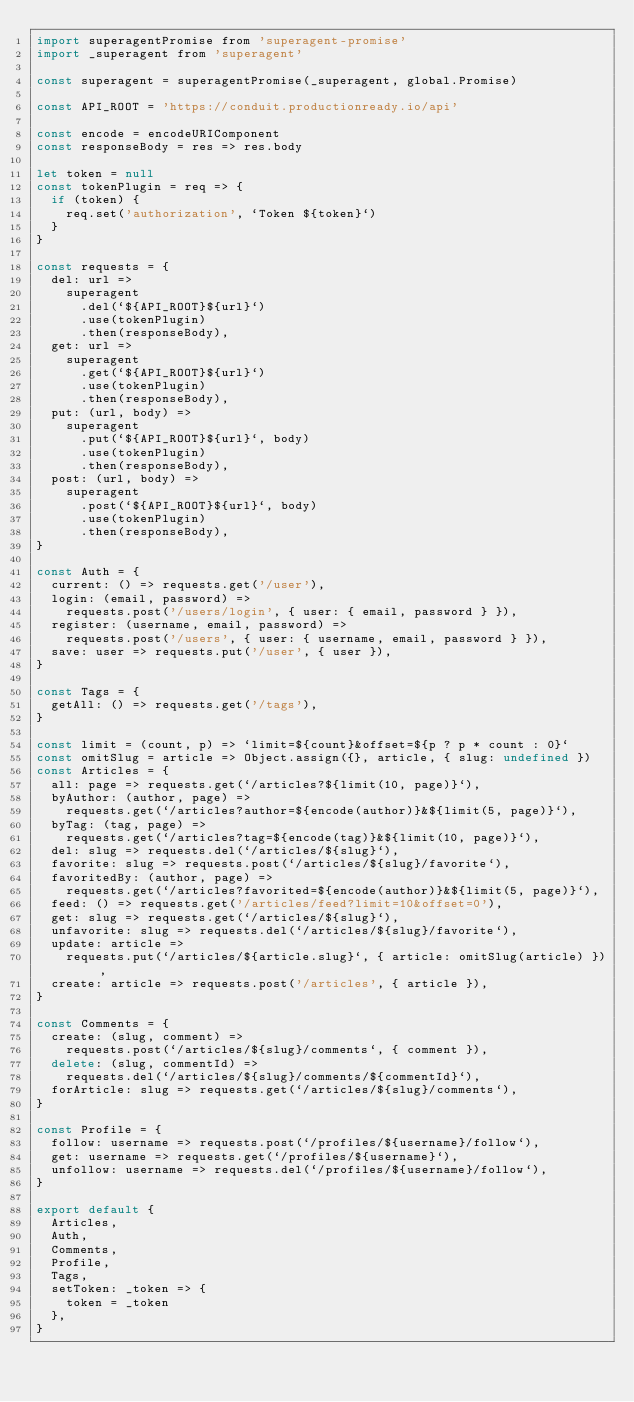<code> <loc_0><loc_0><loc_500><loc_500><_JavaScript_>import superagentPromise from 'superagent-promise'
import _superagent from 'superagent'

const superagent = superagentPromise(_superagent, global.Promise)

const API_ROOT = 'https://conduit.productionready.io/api'

const encode = encodeURIComponent
const responseBody = res => res.body

let token = null
const tokenPlugin = req => {
  if (token) {
    req.set('authorization', `Token ${token}`)
  }
}

const requests = {
  del: url =>
    superagent
      .del(`${API_ROOT}${url}`)
      .use(tokenPlugin)
      .then(responseBody),
  get: url =>
    superagent
      .get(`${API_ROOT}${url}`)
      .use(tokenPlugin)
      .then(responseBody),
  put: (url, body) =>
    superagent
      .put(`${API_ROOT}${url}`, body)
      .use(tokenPlugin)
      .then(responseBody),
  post: (url, body) =>
    superagent
      .post(`${API_ROOT}${url}`, body)
      .use(tokenPlugin)
      .then(responseBody),
}

const Auth = {
  current: () => requests.get('/user'),
  login: (email, password) =>
    requests.post('/users/login', { user: { email, password } }),
  register: (username, email, password) =>
    requests.post('/users', { user: { username, email, password } }),
  save: user => requests.put('/user', { user }),
}

const Tags = {
  getAll: () => requests.get('/tags'),
}

const limit = (count, p) => `limit=${count}&offset=${p ? p * count : 0}`
const omitSlug = article => Object.assign({}, article, { slug: undefined })
const Articles = {
  all: page => requests.get(`/articles?${limit(10, page)}`),
  byAuthor: (author, page) =>
    requests.get(`/articles?author=${encode(author)}&${limit(5, page)}`),
  byTag: (tag, page) =>
    requests.get(`/articles?tag=${encode(tag)}&${limit(10, page)}`),
  del: slug => requests.del(`/articles/${slug}`),
  favorite: slug => requests.post(`/articles/${slug}/favorite`),
  favoritedBy: (author, page) =>
    requests.get(`/articles?favorited=${encode(author)}&${limit(5, page)}`),
  feed: () => requests.get('/articles/feed?limit=10&offset=0'),
  get: slug => requests.get(`/articles/${slug}`),
  unfavorite: slug => requests.del(`/articles/${slug}/favorite`),
  update: article =>
    requests.put(`/articles/${article.slug}`, { article: omitSlug(article) }),
  create: article => requests.post('/articles', { article }),
}

const Comments = {
  create: (slug, comment) =>
    requests.post(`/articles/${slug}/comments`, { comment }),
  delete: (slug, commentId) =>
    requests.del(`/articles/${slug}/comments/${commentId}`),
  forArticle: slug => requests.get(`/articles/${slug}/comments`),
}

const Profile = {
  follow: username => requests.post(`/profiles/${username}/follow`),
  get: username => requests.get(`/profiles/${username}`),
  unfollow: username => requests.del(`/profiles/${username}/follow`),
}

export default {
  Articles,
  Auth,
  Comments,
  Profile,
  Tags,
  setToken: _token => {
    token = _token
  },
}
</code> 